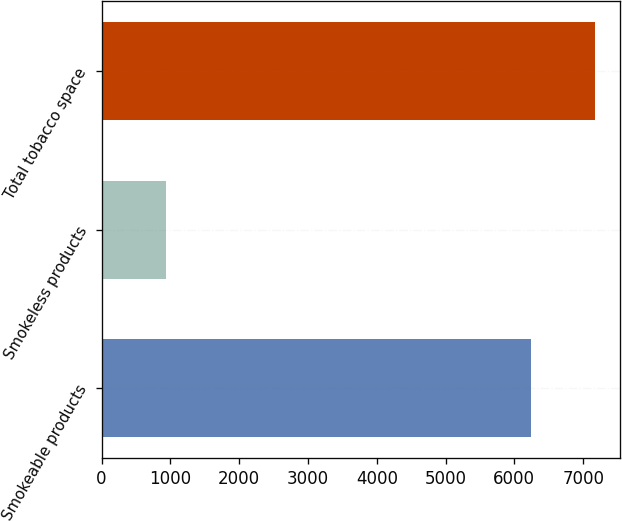Convert chart. <chart><loc_0><loc_0><loc_500><loc_500><bar_chart><fcel>Smokeable products<fcel>Smokeless products<fcel>Total tobacco space<nl><fcel>6239<fcel>931<fcel>7170<nl></chart> 